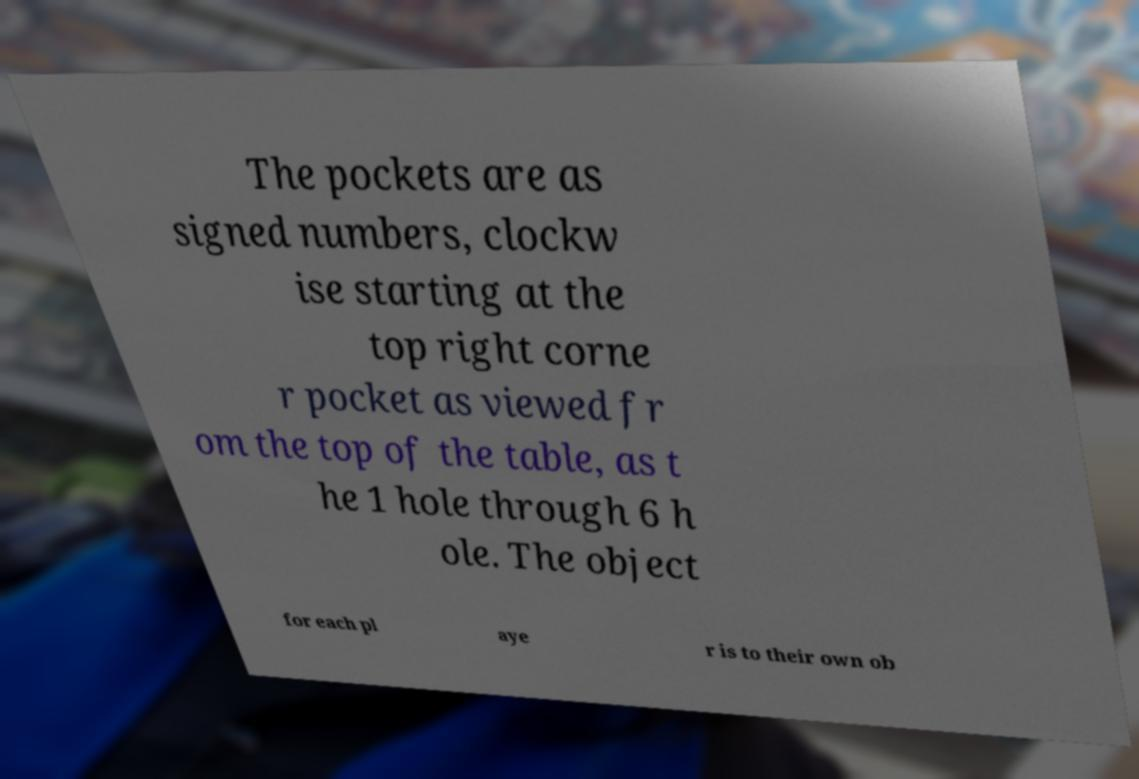What messages or text are displayed in this image? I need them in a readable, typed format. The pockets are as signed numbers, clockw ise starting at the top right corne r pocket as viewed fr om the top of the table, as t he 1 hole through 6 h ole. The object for each pl aye r is to their own ob 